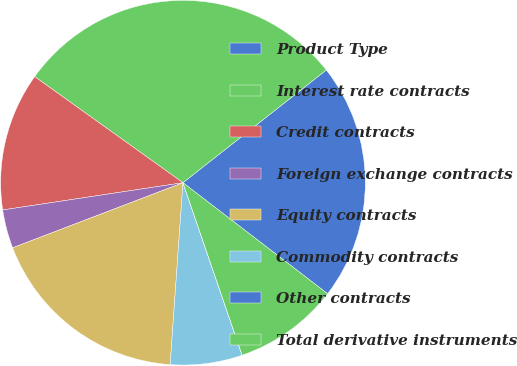<chart> <loc_0><loc_0><loc_500><loc_500><pie_chart><fcel>Product Type<fcel>Interest rate contracts<fcel>Credit contracts<fcel>Foreign exchange contracts<fcel>Equity contracts<fcel>Commodity contracts<fcel>Other contracts<fcel>Total derivative instruments<nl><fcel>21.02%<fcel>29.51%<fcel>12.27%<fcel>3.42%<fcel>18.07%<fcel>6.37%<fcel>0.01%<fcel>9.32%<nl></chart> 